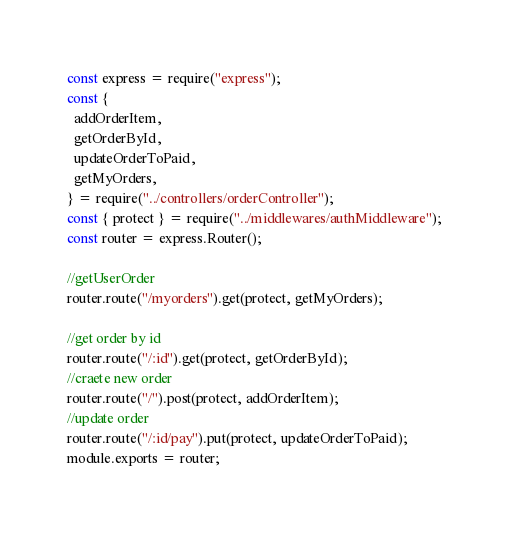<code> <loc_0><loc_0><loc_500><loc_500><_JavaScript_>const express = require("express");
const {
  addOrderItem,
  getOrderById,
  updateOrderToPaid,
  getMyOrders,
} = require("../controllers/orderController");
const { protect } = require("../middlewares/authMiddleware");
const router = express.Router();

//getUserOrder
router.route("/myorders").get(protect, getMyOrders);

//get order by id
router.route("/:id").get(protect, getOrderById);
//craete new order
router.route("/").post(protect, addOrderItem);
//update order
router.route("/:id/pay").put(protect, updateOrderToPaid);
module.exports = router;
</code> 